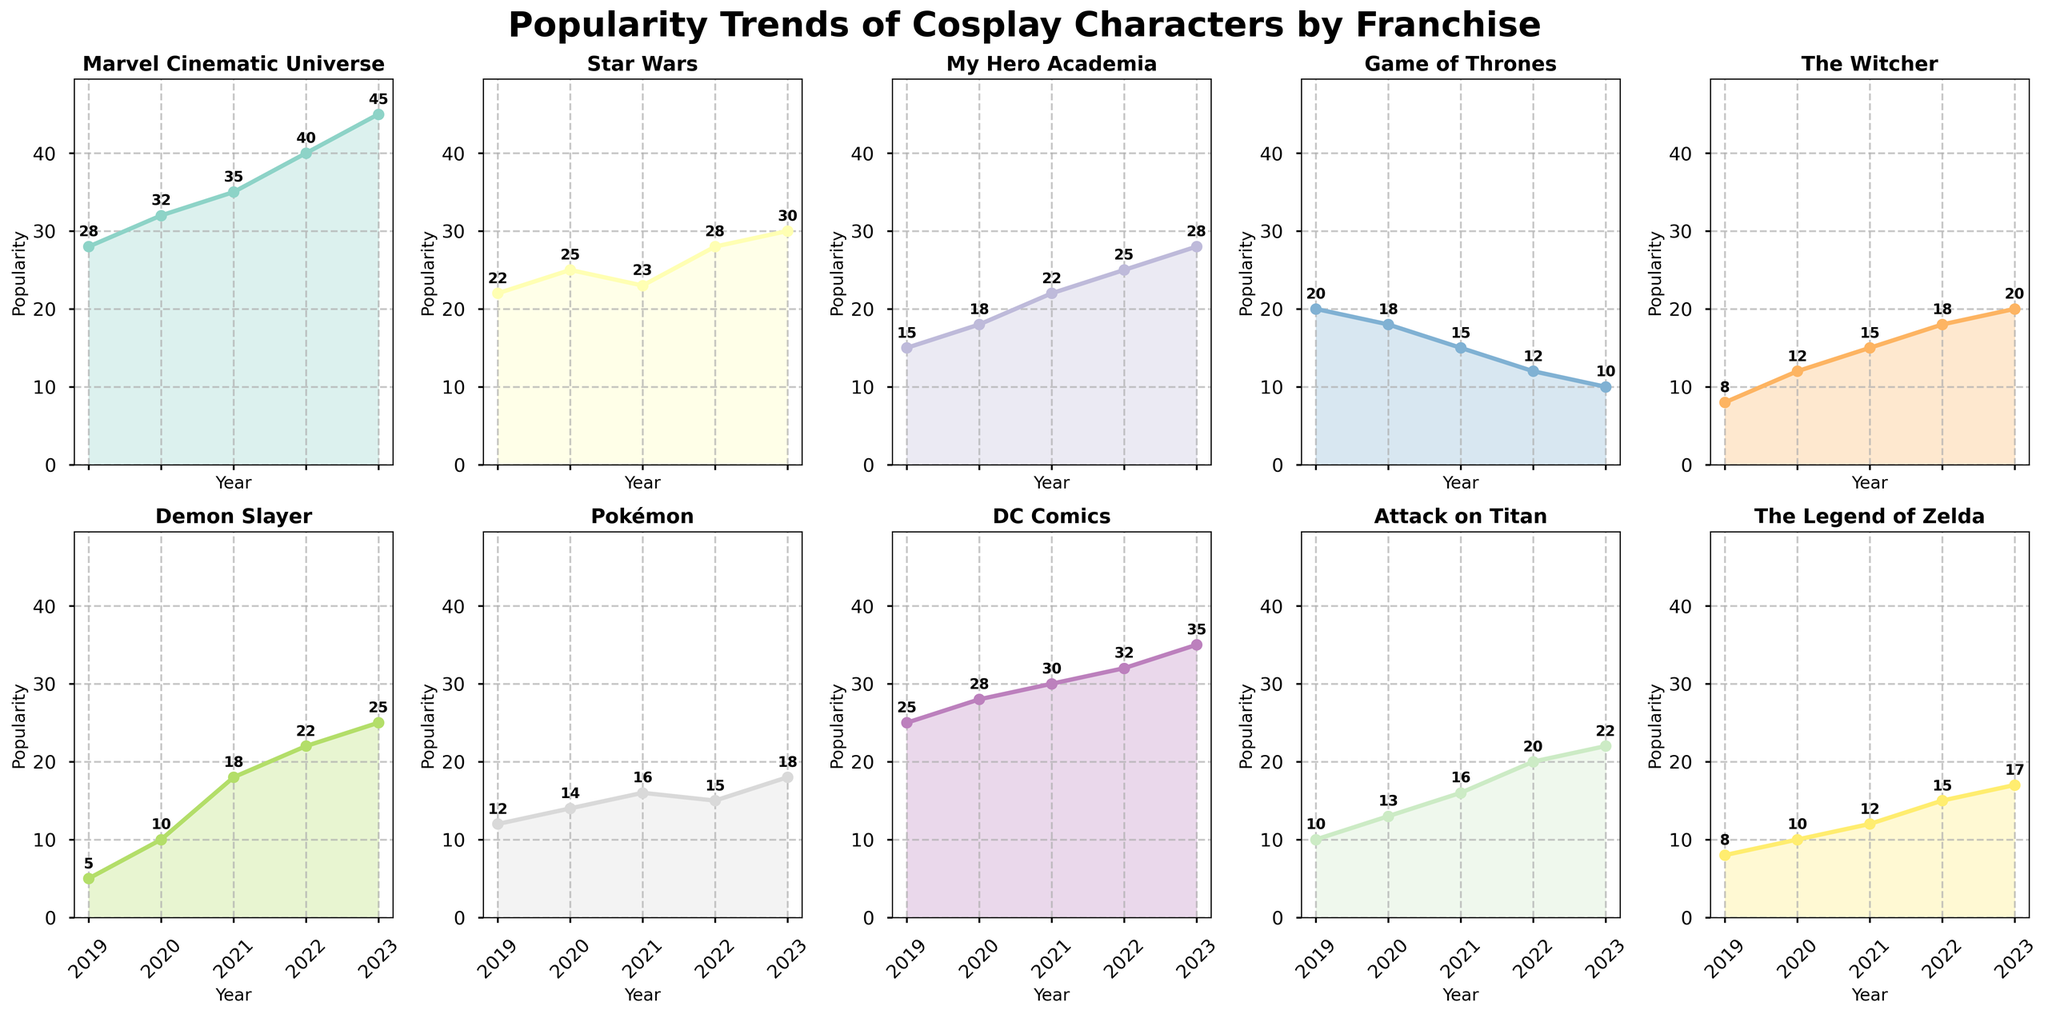Which year had the highest popularity for Marvel Cinematic Universe cosplays? Observing the subplot for the Marvel Cinematic Universe, we note that 2023 has the highest popularity value.
Answer: 2023 How has the popularity of Game of Thrones changed from 2019 to 2023? In 2019, the popularity was 20, and it decreased to 10 in 2023, indicating a steady decline.
Answer: Declined What trend do you observe for Attack on Titan cosplays from 2019 to 2023? The subplot shows a consistent increase each year from 10 (2019) to 22 (2023).
Answer: Consistent increase Which franchise showed the most significant increase in popularity from 2019 to 2023? Comparing the slopes of the trend lines, Demon Slayer shows the most dramatic increase, from 5 in 2019 to 25 in 2023.
Answer: Demon Slayer Which two franchises had similar starting popularity in 2019 but diverged in later years? Pokémon and The Witcher both started with values close to each other (12 and 8 respectively), but by 2023, Pokémon reached 18 while The Witcher reached 20.
Answer: Pokémon and The Witcher By how much did the popularity of DC Comics cosplays increase between 2019 and 2023? The popularity increased from 25 in 2019 to 35 in 2023, thus increasing by 10 units.
Answer: 10 units Identify the franchise with a declining trend over the years. The subplot for Game of Thrones shows a consistent decline from 20 in 2019 to 10 in 2023.
Answer: Game of Thrones What is the average popularity of cosplays for Star Wars from 2019 to 2023? Adding the values (22, 25, 23, 28, 30) gives a total of 128. Dividing by 5 data points, the average is 25.6.
Answer: 25.6 Which year had the biggest increase in popularity for any franchise, and which franchise was it? Observing subplots, Demon Slayer shows the biggest jump between 2019 and 2020, increasing by 5 to 10.
Answer: 2019 to 2020, Demon Slayer Compare the popularity trends of Marvel Cinematic Universe and DC Comics up to 2023. Both show increasing trends, but Marvel starts at 28 and ends at 45, while DC starts at 25 and ends at 35, indicating Marvel had a higher increase overall.
Answer: Marvel increased more 